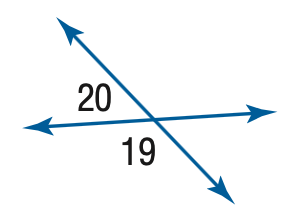Question: m \angle 19 = 100 + 20 x, m \angle 20 = 20 x. Find the measure of \angle 19.
Choices:
A. 100
B. 120
C. 140
D. 160
Answer with the letter. Answer: C 